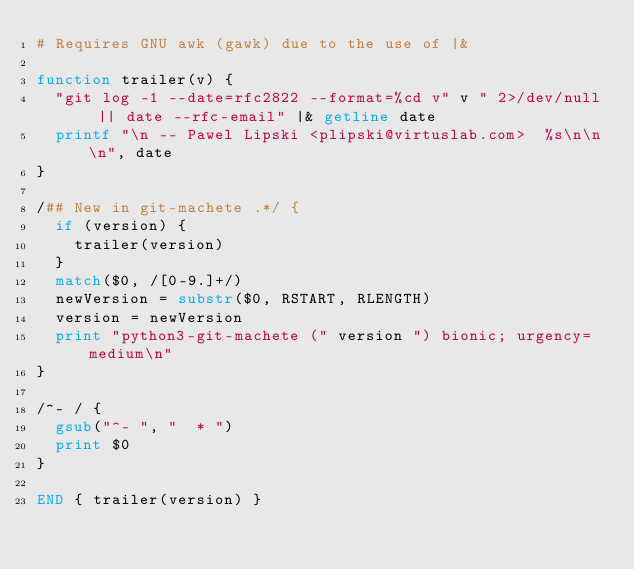<code> <loc_0><loc_0><loc_500><loc_500><_Awk_># Requires GNU awk (gawk) due to the use of |&

function trailer(v) {
  "git log -1 --date=rfc2822 --format=%cd v" v " 2>/dev/null || date --rfc-email" |& getline date
  printf "\n -- Pawel Lipski <plipski@virtuslab.com>  %s\n\n\n", date
}

/## New in git-machete .*/ {
  if (version) {
    trailer(version)
  }
  match($0, /[0-9.]+/)
  newVersion = substr($0, RSTART, RLENGTH)
  version = newVersion
  print "python3-git-machete (" version ") bionic; urgency=medium\n"
}

/^- / {
  gsub("^- ", "  * ")
  print $0
}

END { trailer(version) }
</code> 